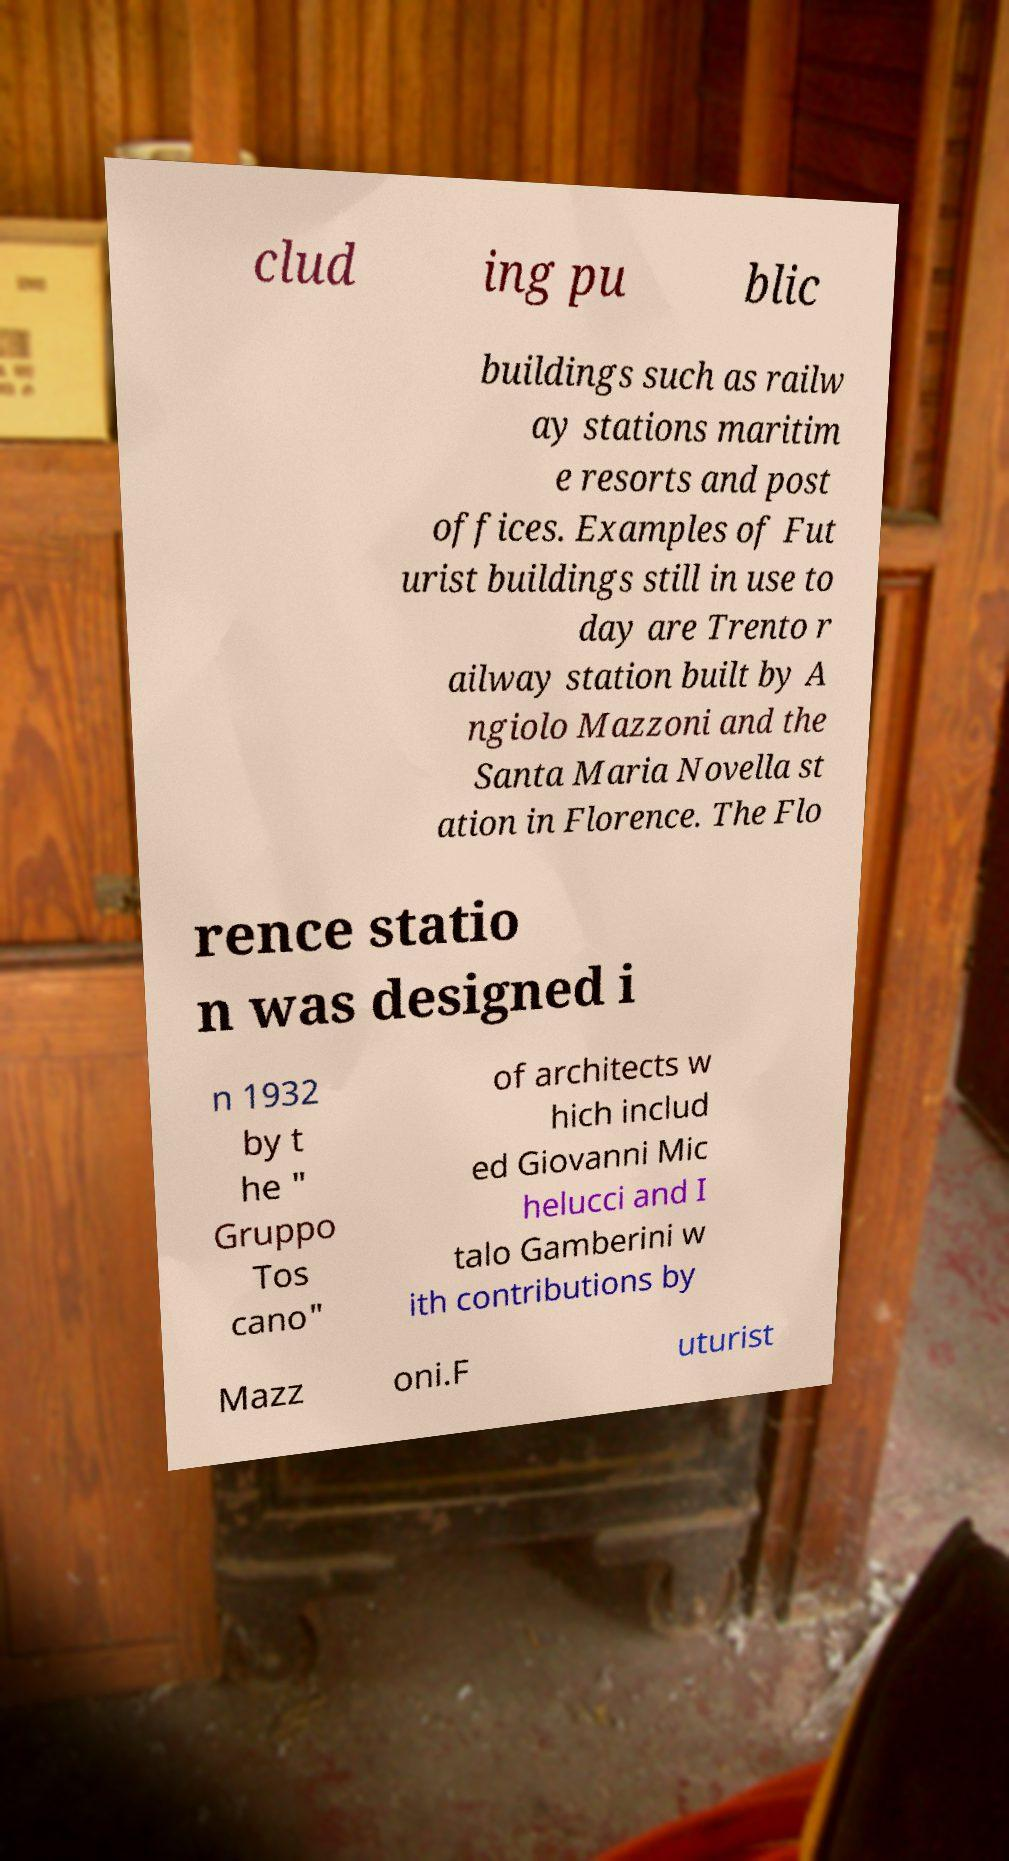I need the written content from this picture converted into text. Can you do that? clud ing pu blic buildings such as railw ay stations maritim e resorts and post offices. Examples of Fut urist buildings still in use to day are Trento r ailway station built by A ngiolo Mazzoni and the Santa Maria Novella st ation in Florence. The Flo rence statio n was designed i n 1932 by t he " Gruppo Tos cano" of architects w hich includ ed Giovanni Mic helucci and I talo Gamberini w ith contributions by Mazz oni.F uturist 